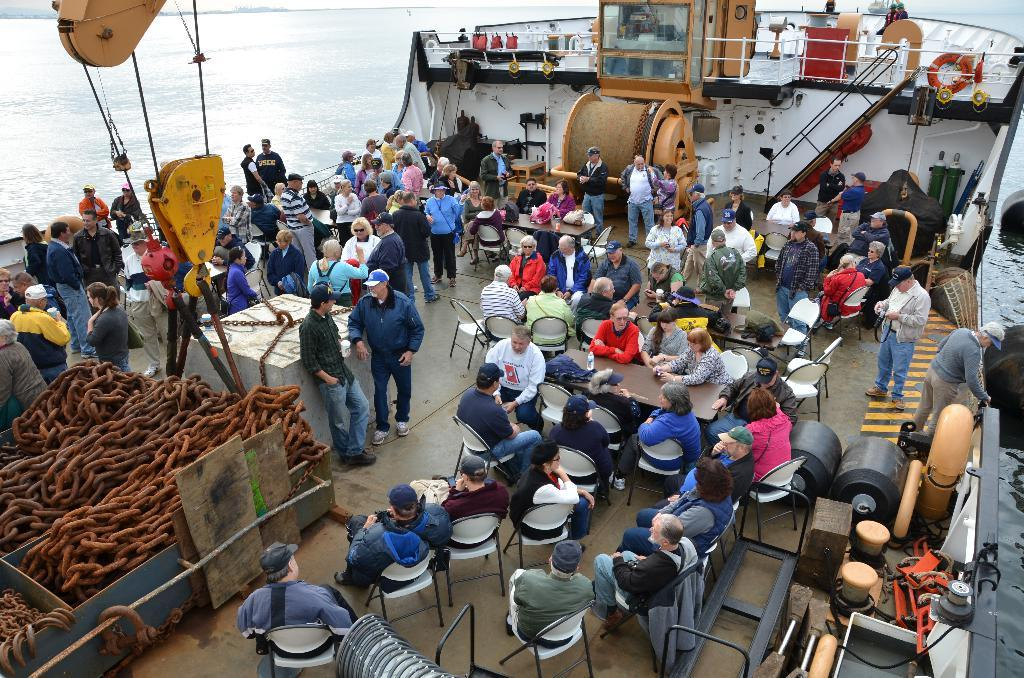How many people are in the image? There are many people in the image. What are the people doing in the image? The people are standing and sitting around a table. Where is the table located? The table is on a ship. What can be seen on the left side of the ship? There are chains on the left side of the ship. What is hanging above the chains? A crane is hanging above the chains. What body of water is the ship in? The ship is in the ocean. What type of robin can be seen flying over the ship in the image? There is no robin present in the image; it is set on a ship in the ocean. How much salt is visible on the table in the image? There is no salt visible on the table in the image. 